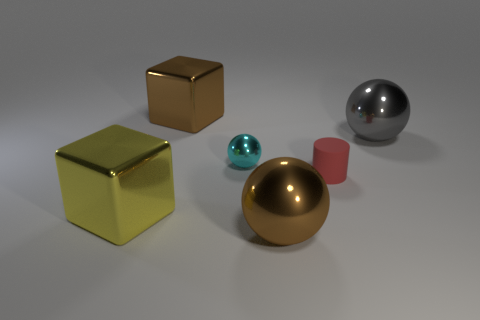Subtract all big shiny balls. How many balls are left? 1 Add 1 big brown shiny blocks. How many objects exist? 7 Subtract all cylinders. How many objects are left? 5 Subtract all brown metal balls. Subtract all metal objects. How many objects are left? 0 Add 4 brown metal balls. How many brown metal balls are left? 5 Add 6 small cyan things. How many small cyan things exist? 7 Subtract 0 green balls. How many objects are left? 6 